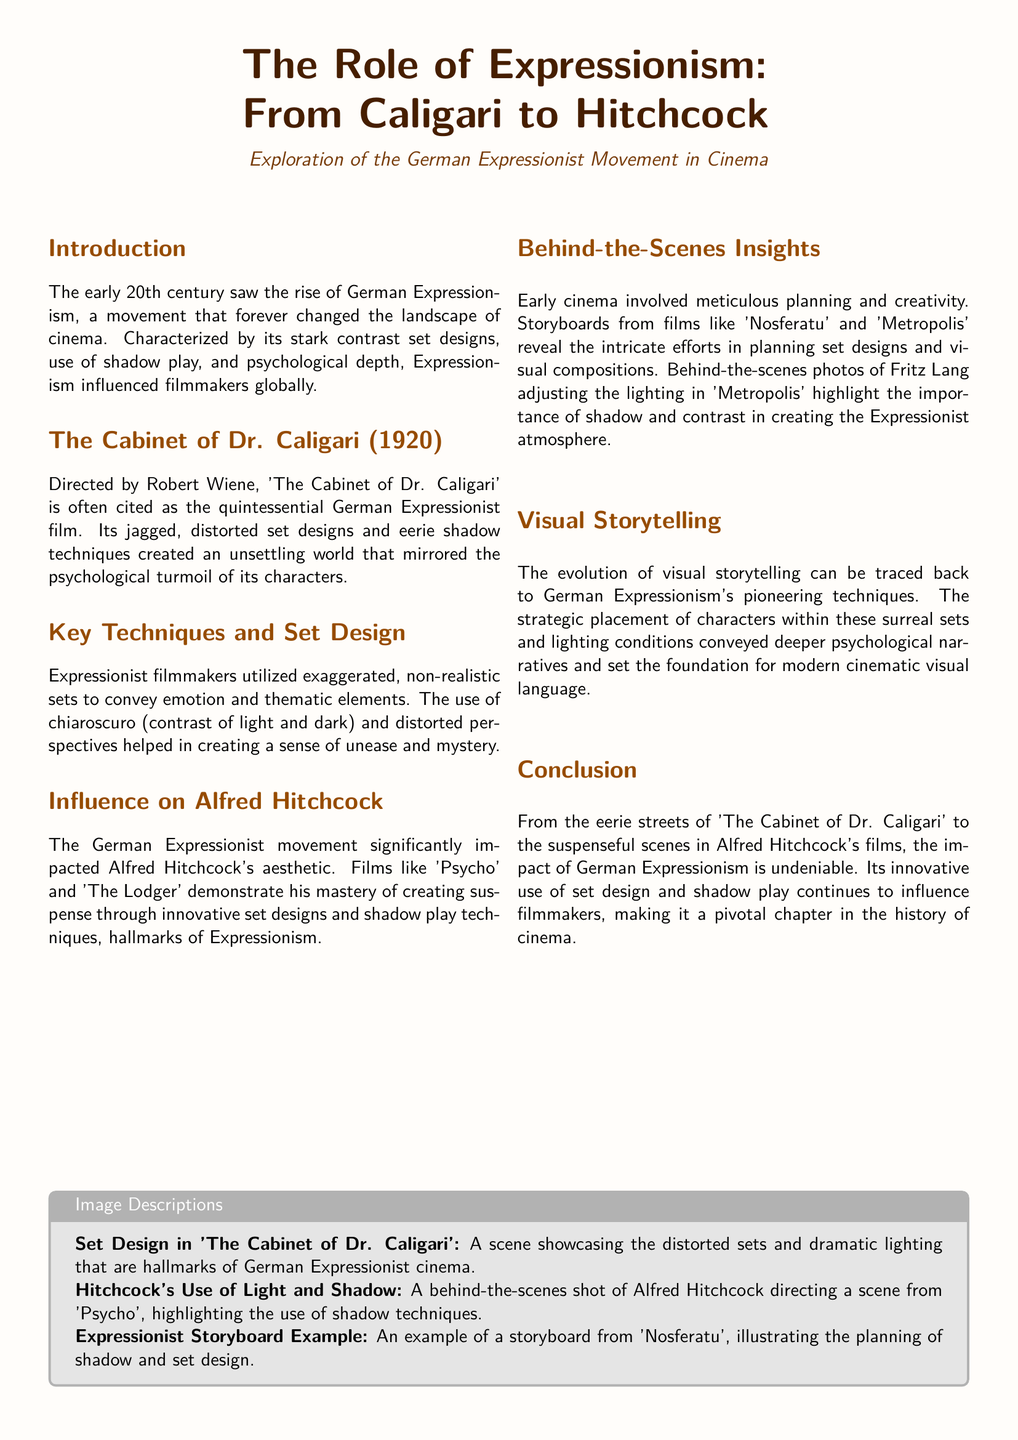What is the title of the first film discussed? The title of the first film mentioned in the document is 'The Cabinet of Dr. Caligari'.
Answer: 'The Cabinet of Dr. Caligari' Who directed 'The Cabinet of Dr. Caligari'? The document states that Robert Wiene directed 'The Cabinet of Dr. Caligari'.
Answer: Robert Wiene What aesthetic techniques influenced Alfred Hitchcock? The document indicates that Hitchcock's films were influenced by the use of shadow play techniques from Expressionism.
Answer: Shadow play techniques What year was 'The Cabinet of Dr. Caligari' released? The release year of 'The Cabinet of Dr. Caligari' is specified in the document as 1920.
Answer: 1920 Which film is an example of Alfred Hitchcock's work influenced by Expressionism? 'Psycho' is mentioned as an example of Hitchcock's work influenced by Expressionism.
Answer: 'Psycho' What is emphasized in the behind-the-scenes photos discussed? The emphasis in the behind-the-scenes photos is on the importance of shadow and contrast in creating atmosphere.
Answer: Shadow and contrast What narrative element did German Expressionism help convey? The document notes that German Expressionism conveyed deeper psychological narratives in visual storytelling.
Answer: Deeper psychological narratives What are the two contrasting aspects of set designs mentioned? The document highlights stark contrast set designs and distorted perspectives as key aspects.
Answer: Stark contrast set designs and distorted perspectives What type of planning is mentioned in relation to early cinema? The document discusses meticulous planning in creating set designs and visual compositions for early cinema.
Answer: Meticulous planning 